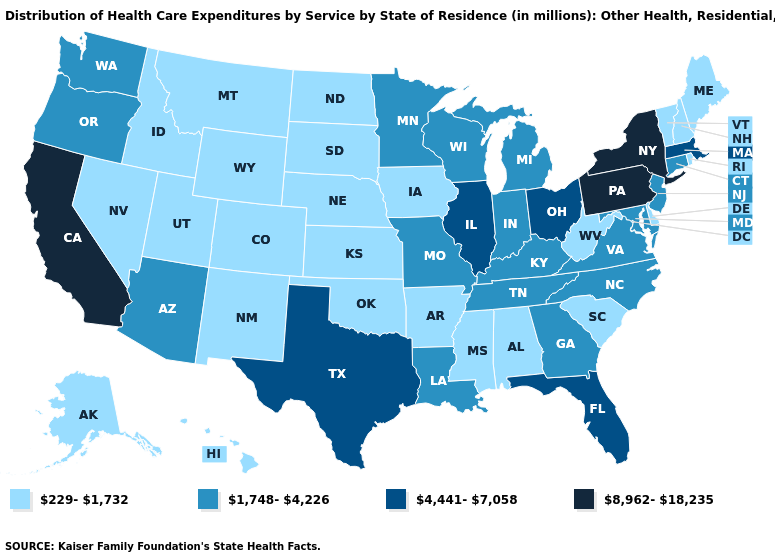Among the states that border Utah , which have the highest value?
Concise answer only. Arizona. Does Missouri have a higher value than Minnesota?
Concise answer only. No. What is the value of Alabama?
Quick response, please. 229-1,732. Name the states that have a value in the range 229-1,732?
Give a very brief answer. Alabama, Alaska, Arkansas, Colorado, Delaware, Hawaii, Idaho, Iowa, Kansas, Maine, Mississippi, Montana, Nebraska, Nevada, New Hampshire, New Mexico, North Dakota, Oklahoma, Rhode Island, South Carolina, South Dakota, Utah, Vermont, West Virginia, Wyoming. Among the states that border South Dakota , does Minnesota have the lowest value?
Write a very short answer. No. What is the lowest value in the USA?
Give a very brief answer. 229-1,732. Does Louisiana have a lower value than Oregon?
Keep it brief. No. Does Washington have a lower value than Virginia?
Give a very brief answer. No. Is the legend a continuous bar?
Be succinct. No. What is the lowest value in states that border Colorado?
Write a very short answer. 229-1,732. Name the states that have a value in the range 8,962-18,235?
Quick response, please. California, New York, Pennsylvania. Does the map have missing data?
Short answer required. No. Which states hav the highest value in the West?
Be succinct. California. Name the states that have a value in the range 8,962-18,235?
Concise answer only. California, New York, Pennsylvania. Among the states that border South Dakota , does North Dakota have the lowest value?
Be succinct. Yes. 